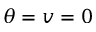Convert formula to latex. <formula><loc_0><loc_0><loc_500><loc_500>\theta = v = 0</formula> 